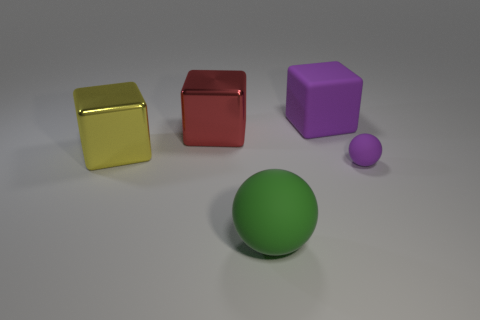Can you describe the arrangement of the different colored objects seen in the image? Certainly, the image displays an assortment of geometric shapes with different colors and finishes. Starting from the left there is a glossy yellow cube, followed by a shiny red cube, a green sphere in the center, a purple cube with a matte finish, and a smaller purple sphere. They are arranged on a flat surface with a neutral background, providing a variety of hues and textures. 